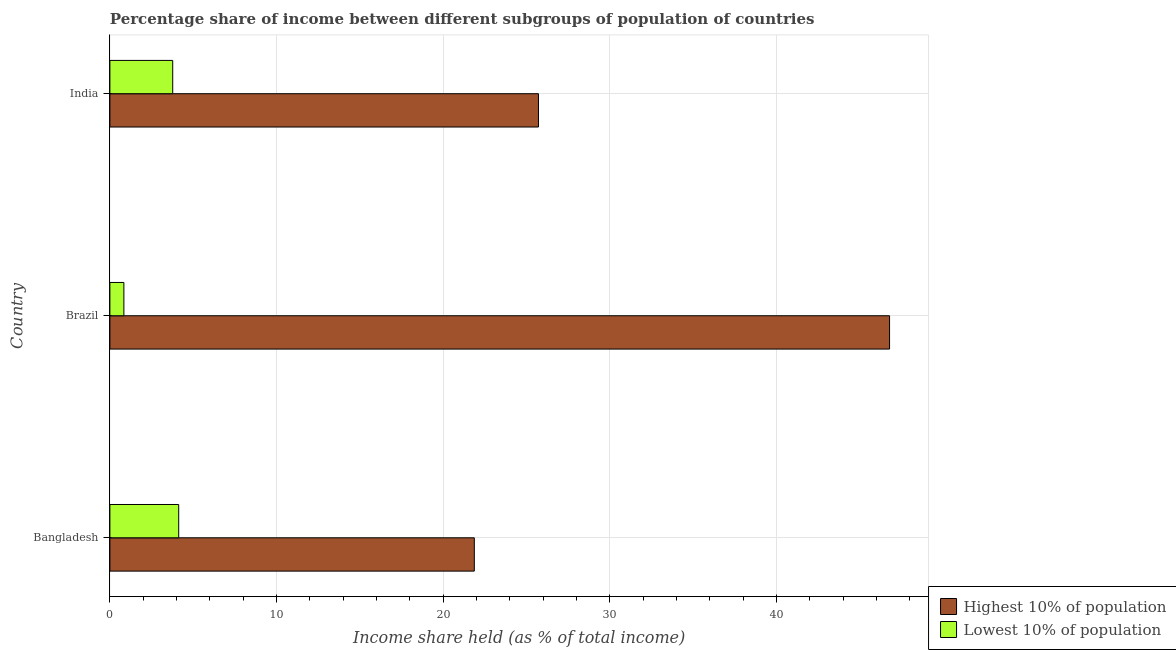How many different coloured bars are there?
Your response must be concise. 2. How many bars are there on the 3rd tick from the bottom?
Offer a very short reply. 2. What is the label of the 2nd group of bars from the top?
Make the answer very short. Brazil. In how many cases, is the number of bars for a given country not equal to the number of legend labels?
Provide a succinct answer. 0. What is the income share held by lowest 10% of the population in Brazil?
Provide a succinct answer. 0.84. Across all countries, what is the maximum income share held by highest 10% of the population?
Ensure brevity in your answer.  46.79. Across all countries, what is the minimum income share held by highest 10% of the population?
Offer a very short reply. 21.87. What is the total income share held by lowest 10% of the population in the graph?
Offer a terse response. 8.74. What is the difference between the income share held by lowest 10% of the population in Bangladesh and that in Brazil?
Give a very brief answer. 3.29. What is the difference between the income share held by highest 10% of the population in Bangladesh and the income share held by lowest 10% of the population in Brazil?
Your answer should be compact. 21.03. What is the average income share held by lowest 10% of the population per country?
Provide a succinct answer. 2.91. What is the difference between the income share held by highest 10% of the population and income share held by lowest 10% of the population in Bangladesh?
Your answer should be very brief. 17.74. In how many countries, is the income share held by lowest 10% of the population greater than 18 %?
Keep it short and to the point. 0. What is the ratio of the income share held by lowest 10% of the population in Bangladesh to that in Brazil?
Your answer should be compact. 4.92. What is the difference between the highest and the second highest income share held by lowest 10% of the population?
Your answer should be compact. 0.36. What is the difference between the highest and the lowest income share held by highest 10% of the population?
Make the answer very short. 24.92. In how many countries, is the income share held by lowest 10% of the population greater than the average income share held by lowest 10% of the population taken over all countries?
Offer a terse response. 2. Is the sum of the income share held by lowest 10% of the population in Brazil and India greater than the maximum income share held by highest 10% of the population across all countries?
Provide a succinct answer. No. What does the 1st bar from the top in Bangladesh represents?
Offer a very short reply. Lowest 10% of population. What does the 2nd bar from the bottom in Bangladesh represents?
Keep it short and to the point. Lowest 10% of population. Where does the legend appear in the graph?
Ensure brevity in your answer.  Bottom right. How many legend labels are there?
Provide a succinct answer. 2. How are the legend labels stacked?
Offer a terse response. Vertical. What is the title of the graph?
Provide a succinct answer. Percentage share of income between different subgroups of population of countries. What is the label or title of the X-axis?
Make the answer very short. Income share held (as % of total income). What is the Income share held (as % of total income) of Highest 10% of population in Bangladesh?
Ensure brevity in your answer.  21.87. What is the Income share held (as % of total income) of Lowest 10% of population in Bangladesh?
Ensure brevity in your answer.  4.13. What is the Income share held (as % of total income) of Highest 10% of population in Brazil?
Offer a very short reply. 46.79. What is the Income share held (as % of total income) in Lowest 10% of population in Brazil?
Provide a short and direct response. 0.84. What is the Income share held (as % of total income) of Highest 10% of population in India?
Give a very brief answer. 25.72. What is the Income share held (as % of total income) of Lowest 10% of population in India?
Provide a succinct answer. 3.77. Across all countries, what is the maximum Income share held (as % of total income) of Highest 10% of population?
Provide a succinct answer. 46.79. Across all countries, what is the maximum Income share held (as % of total income) of Lowest 10% of population?
Give a very brief answer. 4.13. Across all countries, what is the minimum Income share held (as % of total income) in Highest 10% of population?
Provide a short and direct response. 21.87. Across all countries, what is the minimum Income share held (as % of total income) of Lowest 10% of population?
Give a very brief answer. 0.84. What is the total Income share held (as % of total income) of Highest 10% of population in the graph?
Give a very brief answer. 94.38. What is the total Income share held (as % of total income) in Lowest 10% of population in the graph?
Make the answer very short. 8.74. What is the difference between the Income share held (as % of total income) of Highest 10% of population in Bangladesh and that in Brazil?
Give a very brief answer. -24.92. What is the difference between the Income share held (as % of total income) of Lowest 10% of population in Bangladesh and that in Brazil?
Provide a succinct answer. 3.29. What is the difference between the Income share held (as % of total income) of Highest 10% of population in Bangladesh and that in India?
Your answer should be compact. -3.85. What is the difference between the Income share held (as % of total income) in Lowest 10% of population in Bangladesh and that in India?
Provide a succinct answer. 0.36. What is the difference between the Income share held (as % of total income) of Highest 10% of population in Brazil and that in India?
Provide a succinct answer. 21.07. What is the difference between the Income share held (as % of total income) in Lowest 10% of population in Brazil and that in India?
Make the answer very short. -2.93. What is the difference between the Income share held (as % of total income) of Highest 10% of population in Bangladesh and the Income share held (as % of total income) of Lowest 10% of population in Brazil?
Offer a terse response. 21.03. What is the difference between the Income share held (as % of total income) of Highest 10% of population in Brazil and the Income share held (as % of total income) of Lowest 10% of population in India?
Your response must be concise. 43.02. What is the average Income share held (as % of total income) in Highest 10% of population per country?
Your answer should be very brief. 31.46. What is the average Income share held (as % of total income) in Lowest 10% of population per country?
Your response must be concise. 2.91. What is the difference between the Income share held (as % of total income) in Highest 10% of population and Income share held (as % of total income) in Lowest 10% of population in Bangladesh?
Make the answer very short. 17.74. What is the difference between the Income share held (as % of total income) in Highest 10% of population and Income share held (as % of total income) in Lowest 10% of population in Brazil?
Your response must be concise. 45.95. What is the difference between the Income share held (as % of total income) in Highest 10% of population and Income share held (as % of total income) in Lowest 10% of population in India?
Make the answer very short. 21.95. What is the ratio of the Income share held (as % of total income) in Highest 10% of population in Bangladesh to that in Brazil?
Offer a very short reply. 0.47. What is the ratio of the Income share held (as % of total income) of Lowest 10% of population in Bangladesh to that in Brazil?
Give a very brief answer. 4.92. What is the ratio of the Income share held (as % of total income) of Highest 10% of population in Bangladesh to that in India?
Your answer should be compact. 0.85. What is the ratio of the Income share held (as % of total income) of Lowest 10% of population in Bangladesh to that in India?
Keep it short and to the point. 1.1. What is the ratio of the Income share held (as % of total income) of Highest 10% of population in Brazil to that in India?
Keep it short and to the point. 1.82. What is the ratio of the Income share held (as % of total income) of Lowest 10% of population in Brazil to that in India?
Offer a very short reply. 0.22. What is the difference between the highest and the second highest Income share held (as % of total income) in Highest 10% of population?
Provide a short and direct response. 21.07. What is the difference between the highest and the second highest Income share held (as % of total income) in Lowest 10% of population?
Make the answer very short. 0.36. What is the difference between the highest and the lowest Income share held (as % of total income) in Highest 10% of population?
Make the answer very short. 24.92. What is the difference between the highest and the lowest Income share held (as % of total income) in Lowest 10% of population?
Provide a short and direct response. 3.29. 